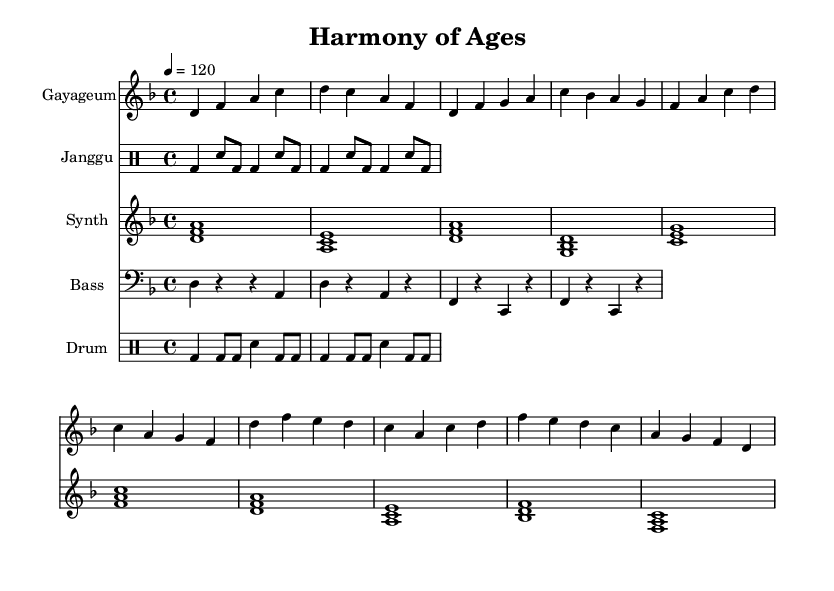What is the key signature of this music? The key signature is D minor, which contains one flat (B flat).
Answer: D minor What is the time signature of this music? The time signature is 4/4, indicating four beats per measure.
Answer: 4/4 What is the tempo of the piece? The tempo is indicated as 120 beats per minute, meaning the quarter note gets the beat.
Answer: 120 How many instruments are featured in this score? There are four instruments featured: Gayageum, Janggu, Synth, and Bass.
Answer: Four Which traditional Korean instrument is used in this composition? The traditional Korean instrument featured is the Gayageum, which is a string instrument.
Answer: Gayageum What type of rhythm pattern does the Janggu play? The Janggu plays a combination of bass drum and snare patterns, which are typical in Korean drumming styles.
Answer: Combination How do modern beats integrate with traditional sounds in this piece? The modern beats, as indicated by the Synth and Drum elements, blend with traditional rhythms and melodies from the Gayageum and Janggu, creating a fusion style characteristic of K-Pop.
Answer: Fusion style 